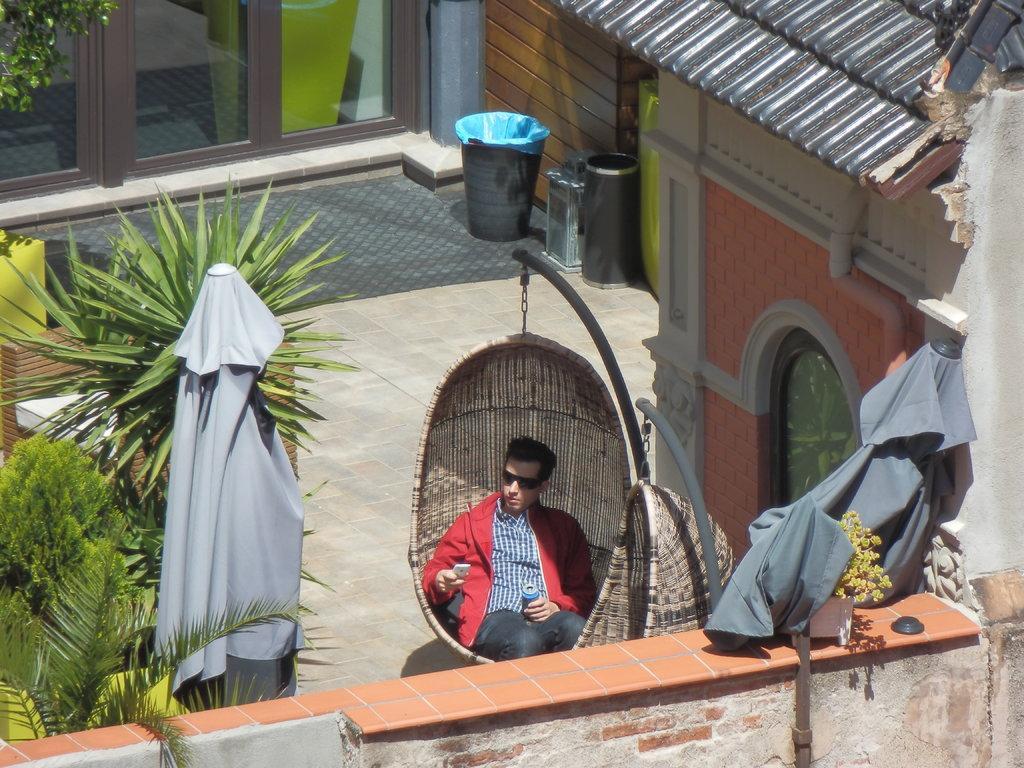Can you describe this image briefly? In this image we can see a man sitting on a hanging swing chair holding a cellphone and a tin. We can also see the tents, a swing chair to a pole, a wall, some plants, trash bins and a house with the windows. 